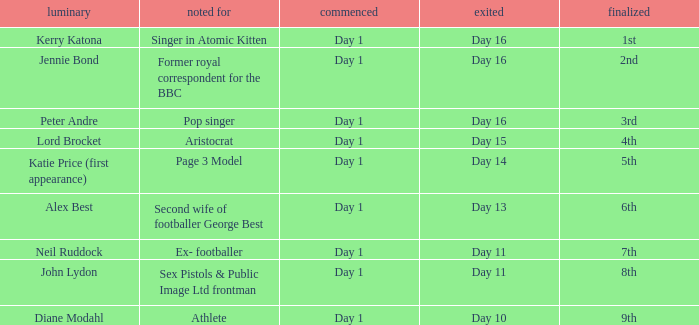Name who was famous for finished in 9th Athlete. 